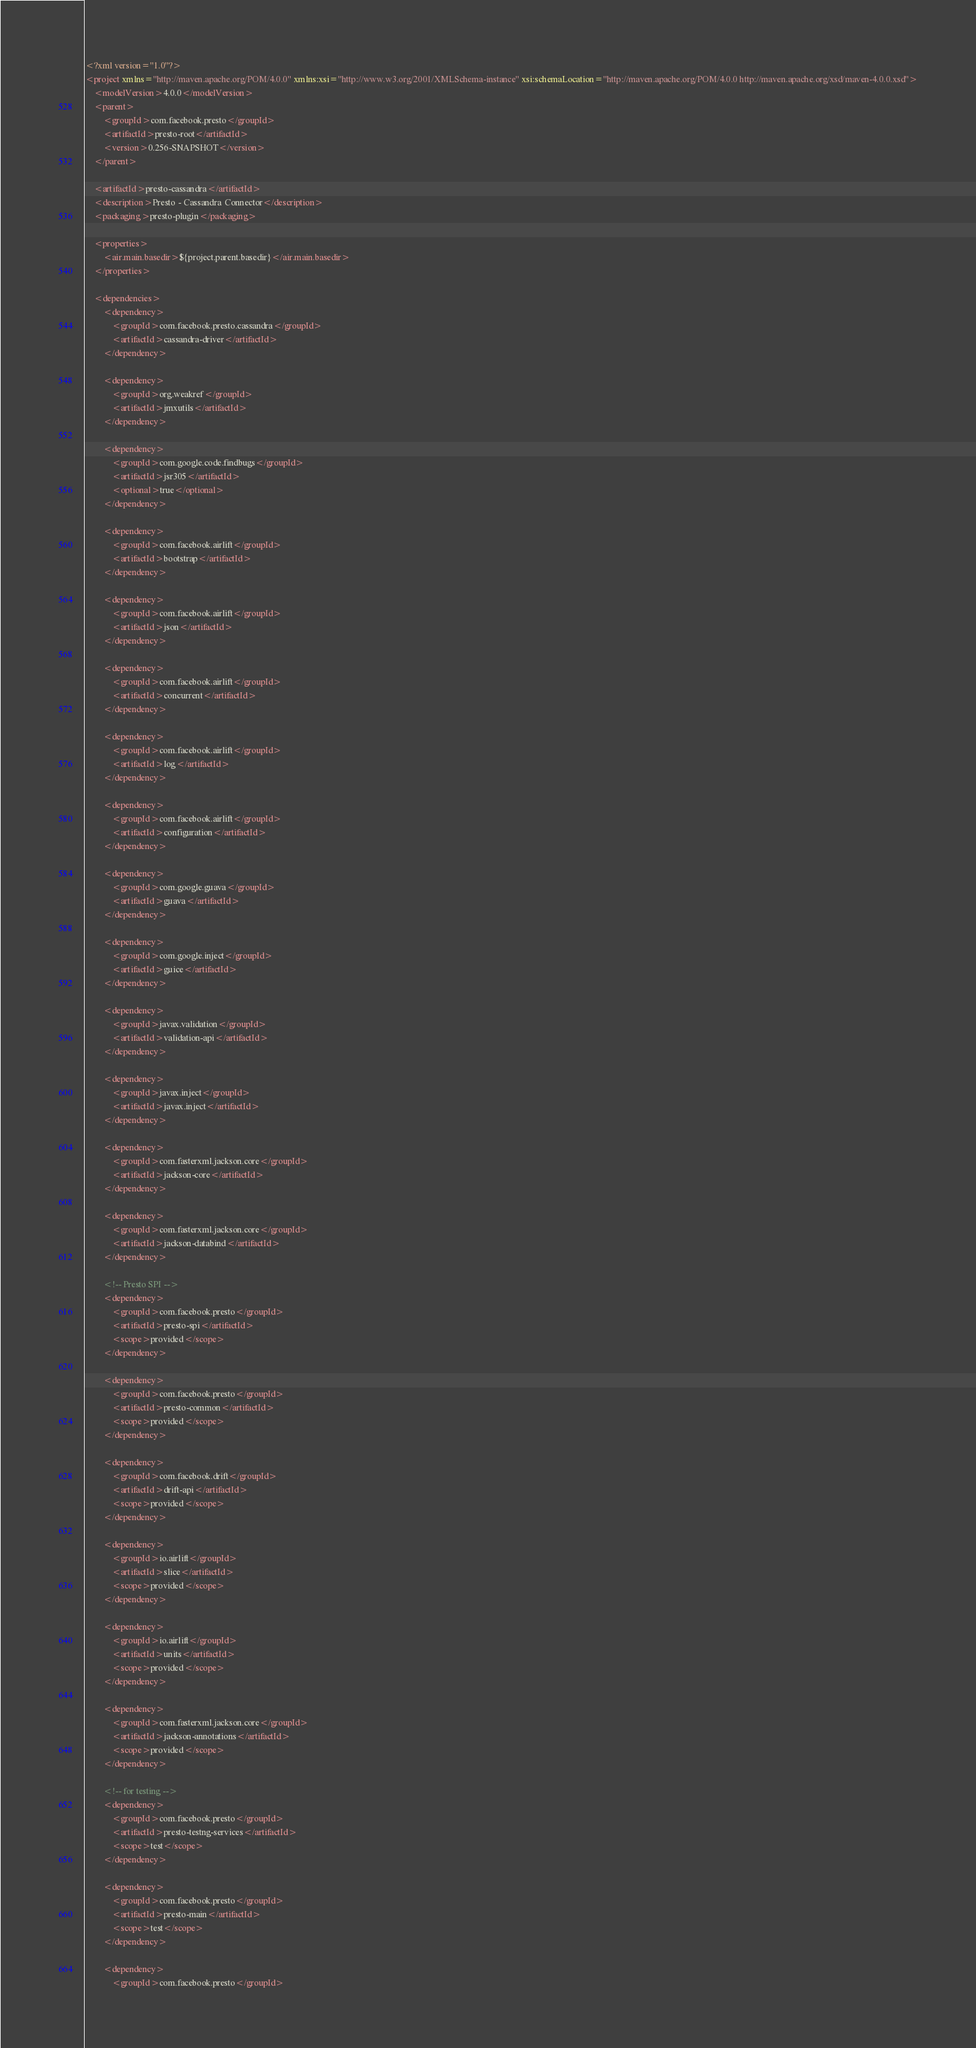<code> <loc_0><loc_0><loc_500><loc_500><_XML_><?xml version="1.0"?>
<project xmlns="http://maven.apache.org/POM/4.0.0" xmlns:xsi="http://www.w3.org/2001/XMLSchema-instance" xsi:schemaLocation="http://maven.apache.org/POM/4.0.0 http://maven.apache.org/xsd/maven-4.0.0.xsd">
    <modelVersion>4.0.0</modelVersion>
    <parent>
        <groupId>com.facebook.presto</groupId>
        <artifactId>presto-root</artifactId>
        <version>0.256-SNAPSHOT</version>
    </parent>

    <artifactId>presto-cassandra</artifactId>
    <description>Presto - Cassandra Connector</description>
    <packaging>presto-plugin</packaging>

    <properties>
        <air.main.basedir>${project.parent.basedir}</air.main.basedir>
    </properties>

    <dependencies>
        <dependency>
            <groupId>com.facebook.presto.cassandra</groupId>
            <artifactId>cassandra-driver</artifactId>
        </dependency>

        <dependency>
            <groupId>org.weakref</groupId>
            <artifactId>jmxutils</artifactId>
        </dependency>

        <dependency>
            <groupId>com.google.code.findbugs</groupId>
            <artifactId>jsr305</artifactId>
            <optional>true</optional>
        </dependency>

        <dependency>
            <groupId>com.facebook.airlift</groupId>
            <artifactId>bootstrap</artifactId>
        </dependency>

        <dependency>
            <groupId>com.facebook.airlift</groupId>
            <artifactId>json</artifactId>
        </dependency>

        <dependency>
            <groupId>com.facebook.airlift</groupId>
            <artifactId>concurrent</artifactId>
        </dependency>

        <dependency>
            <groupId>com.facebook.airlift</groupId>
            <artifactId>log</artifactId>
        </dependency>

        <dependency>
            <groupId>com.facebook.airlift</groupId>
            <artifactId>configuration</artifactId>
        </dependency>

        <dependency>
            <groupId>com.google.guava</groupId>
            <artifactId>guava</artifactId>
        </dependency>

        <dependency>
            <groupId>com.google.inject</groupId>
            <artifactId>guice</artifactId>
        </dependency>

        <dependency>
            <groupId>javax.validation</groupId>
            <artifactId>validation-api</artifactId>
        </dependency>

        <dependency>
            <groupId>javax.inject</groupId>
            <artifactId>javax.inject</artifactId>
        </dependency>

        <dependency>
            <groupId>com.fasterxml.jackson.core</groupId>
            <artifactId>jackson-core</artifactId>
        </dependency>

        <dependency>
            <groupId>com.fasterxml.jackson.core</groupId>
            <artifactId>jackson-databind</artifactId>
        </dependency>

        <!-- Presto SPI -->
        <dependency>
            <groupId>com.facebook.presto</groupId>
            <artifactId>presto-spi</artifactId>
            <scope>provided</scope>
        </dependency>

        <dependency>
            <groupId>com.facebook.presto</groupId>
            <artifactId>presto-common</artifactId>
            <scope>provided</scope>
        </dependency>

        <dependency>
            <groupId>com.facebook.drift</groupId>
            <artifactId>drift-api</artifactId>
            <scope>provided</scope>
        </dependency>

        <dependency>
            <groupId>io.airlift</groupId>
            <artifactId>slice</artifactId>
            <scope>provided</scope>
        </dependency>

        <dependency>
            <groupId>io.airlift</groupId>
            <artifactId>units</artifactId>
            <scope>provided</scope>
        </dependency>

        <dependency>
            <groupId>com.fasterxml.jackson.core</groupId>
            <artifactId>jackson-annotations</artifactId>
            <scope>provided</scope>
        </dependency>

        <!-- for testing -->
        <dependency>
            <groupId>com.facebook.presto</groupId>
            <artifactId>presto-testng-services</artifactId>
            <scope>test</scope>
        </dependency>

        <dependency>
            <groupId>com.facebook.presto</groupId>
            <artifactId>presto-main</artifactId>
            <scope>test</scope>
        </dependency>

        <dependency>
            <groupId>com.facebook.presto</groupId></code> 